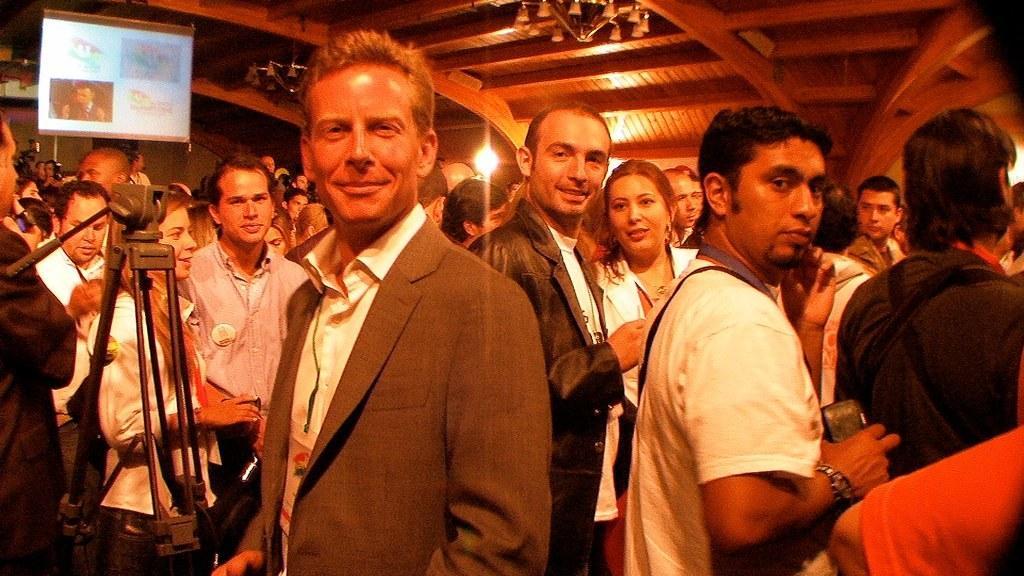Describe this image in one or two sentences. In this image I can see group of persons standing and on the roof I can see a chandelier and light, on the left side I can see a camera and screen 